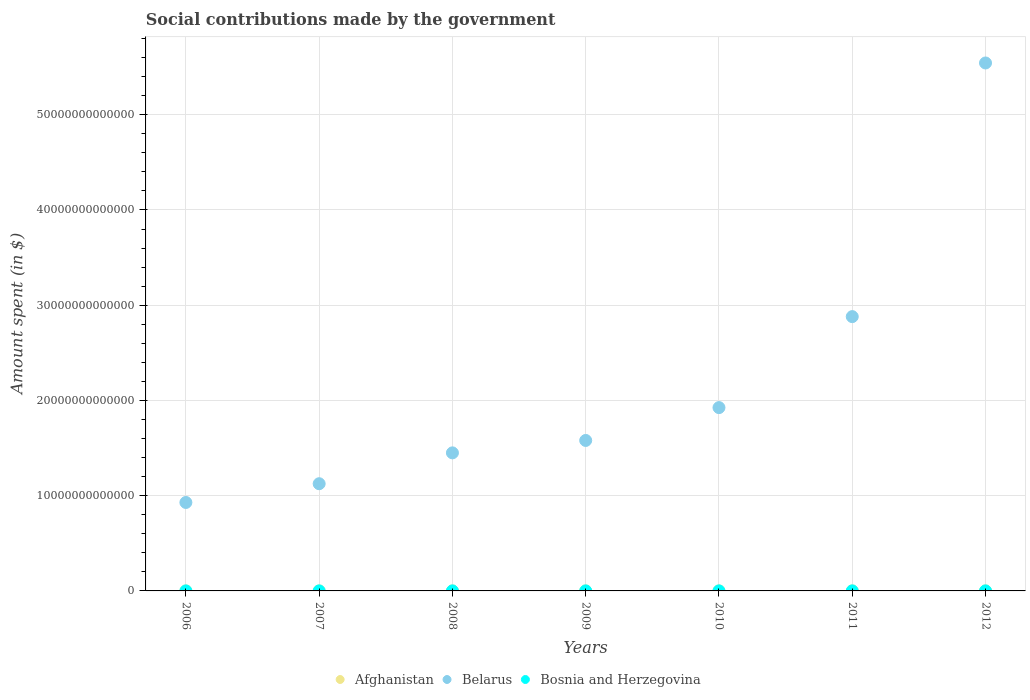How many different coloured dotlines are there?
Your answer should be very brief. 3. What is the amount spent on social contributions in Bosnia and Herzegovina in 2010?
Provide a short and direct response. 3.81e+09. Across all years, what is the maximum amount spent on social contributions in Bosnia and Herzegovina?
Ensure brevity in your answer.  4.05e+09. Across all years, what is the minimum amount spent on social contributions in Afghanistan?
Ensure brevity in your answer.  3.57e+08. In which year was the amount spent on social contributions in Belarus maximum?
Ensure brevity in your answer.  2012. What is the total amount spent on social contributions in Bosnia and Herzegovina in the graph?
Provide a succinct answer. 2.45e+1. What is the difference between the amount spent on social contributions in Belarus in 2008 and that in 2011?
Make the answer very short. -1.43e+13. What is the difference between the amount spent on social contributions in Bosnia and Herzegovina in 2006 and the amount spent on social contributions in Afghanistan in 2008?
Your response must be concise. 1.78e+09. What is the average amount spent on social contributions in Afghanistan per year?
Ensure brevity in your answer.  1.43e+09. In the year 2008, what is the difference between the amount spent on social contributions in Belarus and amount spent on social contributions in Bosnia and Herzegovina?
Make the answer very short. 1.45e+13. In how many years, is the amount spent on social contributions in Belarus greater than 26000000000000 $?
Your response must be concise. 2. What is the ratio of the amount spent on social contributions in Bosnia and Herzegovina in 2006 to that in 2007?
Your answer should be compact. 0.87. Is the amount spent on social contributions in Bosnia and Herzegovina in 2006 less than that in 2012?
Offer a very short reply. Yes. Is the difference between the amount spent on social contributions in Belarus in 2008 and 2010 greater than the difference between the amount spent on social contributions in Bosnia and Herzegovina in 2008 and 2010?
Offer a very short reply. No. What is the difference between the highest and the second highest amount spent on social contributions in Belarus?
Your response must be concise. 2.66e+13. What is the difference between the highest and the lowest amount spent on social contributions in Belarus?
Your response must be concise. 4.61e+13. In how many years, is the amount spent on social contributions in Bosnia and Herzegovina greater than the average amount spent on social contributions in Bosnia and Herzegovina taken over all years?
Ensure brevity in your answer.  5. Does the amount spent on social contributions in Afghanistan monotonically increase over the years?
Offer a terse response. Yes. Is the amount spent on social contributions in Belarus strictly less than the amount spent on social contributions in Bosnia and Herzegovina over the years?
Your response must be concise. No. How many years are there in the graph?
Ensure brevity in your answer.  7. What is the difference between two consecutive major ticks on the Y-axis?
Offer a very short reply. 1.00e+13. Are the values on the major ticks of Y-axis written in scientific E-notation?
Provide a succinct answer. No. Does the graph contain any zero values?
Keep it short and to the point. No. Does the graph contain grids?
Make the answer very short. Yes. Where does the legend appear in the graph?
Give a very brief answer. Bottom center. How are the legend labels stacked?
Your answer should be compact. Horizontal. What is the title of the graph?
Offer a very short reply. Social contributions made by the government. What is the label or title of the Y-axis?
Ensure brevity in your answer.  Amount spent (in $). What is the Amount spent (in $) of Afghanistan in 2006?
Keep it short and to the point. 3.57e+08. What is the Amount spent (in $) in Belarus in 2006?
Keep it short and to the point. 9.29e+12. What is the Amount spent (in $) in Bosnia and Herzegovina in 2006?
Offer a very short reply. 2.54e+09. What is the Amount spent (in $) in Afghanistan in 2007?
Make the answer very short. 3.98e+08. What is the Amount spent (in $) of Belarus in 2007?
Give a very brief answer. 1.13e+13. What is the Amount spent (in $) of Bosnia and Herzegovina in 2007?
Offer a terse response. 2.91e+09. What is the Amount spent (in $) in Afghanistan in 2008?
Offer a terse response. 7.52e+08. What is the Amount spent (in $) of Belarus in 2008?
Ensure brevity in your answer.  1.45e+13. What is the Amount spent (in $) of Bosnia and Herzegovina in 2008?
Give a very brief answer. 3.57e+09. What is the Amount spent (in $) in Afghanistan in 2009?
Your answer should be compact. 9.74e+08. What is the Amount spent (in $) of Belarus in 2009?
Ensure brevity in your answer.  1.58e+13. What is the Amount spent (in $) in Bosnia and Herzegovina in 2009?
Your answer should be compact. 3.64e+09. What is the Amount spent (in $) of Afghanistan in 2010?
Your answer should be compact. 1.65e+09. What is the Amount spent (in $) in Belarus in 2010?
Make the answer very short. 1.92e+13. What is the Amount spent (in $) in Bosnia and Herzegovina in 2010?
Your response must be concise. 3.81e+09. What is the Amount spent (in $) in Afghanistan in 2011?
Your response must be concise. 2.74e+09. What is the Amount spent (in $) of Belarus in 2011?
Your answer should be compact. 2.88e+13. What is the Amount spent (in $) of Bosnia and Herzegovina in 2011?
Provide a short and direct response. 4.04e+09. What is the Amount spent (in $) in Afghanistan in 2012?
Make the answer very short. 3.12e+09. What is the Amount spent (in $) of Belarus in 2012?
Make the answer very short. 5.54e+13. What is the Amount spent (in $) in Bosnia and Herzegovina in 2012?
Your response must be concise. 4.05e+09. Across all years, what is the maximum Amount spent (in $) of Afghanistan?
Your answer should be very brief. 3.12e+09. Across all years, what is the maximum Amount spent (in $) in Belarus?
Give a very brief answer. 5.54e+13. Across all years, what is the maximum Amount spent (in $) in Bosnia and Herzegovina?
Your answer should be very brief. 4.05e+09. Across all years, what is the minimum Amount spent (in $) in Afghanistan?
Provide a short and direct response. 3.57e+08. Across all years, what is the minimum Amount spent (in $) of Belarus?
Your answer should be compact. 9.29e+12. Across all years, what is the minimum Amount spent (in $) of Bosnia and Herzegovina?
Offer a very short reply. 2.54e+09. What is the total Amount spent (in $) in Afghanistan in the graph?
Offer a terse response. 9.99e+09. What is the total Amount spent (in $) in Belarus in the graph?
Your answer should be very brief. 1.54e+14. What is the total Amount spent (in $) of Bosnia and Herzegovina in the graph?
Your answer should be very brief. 2.45e+1. What is the difference between the Amount spent (in $) in Afghanistan in 2006 and that in 2007?
Offer a very short reply. -4.11e+07. What is the difference between the Amount spent (in $) of Belarus in 2006 and that in 2007?
Offer a terse response. -1.97e+12. What is the difference between the Amount spent (in $) of Bosnia and Herzegovina in 2006 and that in 2007?
Provide a short and direct response. -3.73e+08. What is the difference between the Amount spent (in $) of Afghanistan in 2006 and that in 2008?
Your answer should be compact. -3.95e+08. What is the difference between the Amount spent (in $) in Belarus in 2006 and that in 2008?
Your answer should be compact. -5.21e+12. What is the difference between the Amount spent (in $) in Bosnia and Herzegovina in 2006 and that in 2008?
Offer a terse response. -1.03e+09. What is the difference between the Amount spent (in $) of Afghanistan in 2006 and that in 2009?
Give a very brief answer. -6.17e+08. What is the difference between the Amount spent (in $) in Belarus in 2006 and that in 2009?
Your answer should be very brief. -6.51e+12. What is the difference between the Amount spent (in $) of Bosnia and Herzegovina in 2006 and that in 2009?
Your answer should be compact. -1.10e+09. What is the difference between the Amount spent (in $) in Afghanistan in 2006 and that in 2010?
Your answer should be compact. -1.29e+09. What is the difference between the Amount spent (in $) of Belarus in 2006 and that in 2010?
Make the answer very short. -9.96e+12. What is the difference between the Amount spent (in $) of Bosnia and Herzegovina in 2006 and that in 2010?
Offer a very short reply. -1.28e+09. What is the difference between the Amount spent (in $) in Afghanistan in 2006 and that in 2011?
Ensure brevity in your answer.  -2.38e+09. What is the difference between the Amount spent (in $) of Belarus in 2006 and that in 2011?
Make the answer very short. -1.95e+13. What is the difference between the Amount spent (in $) of Bosnia and Herzegovina in 2006 and that in 2011?
Ensure brevity in your answer.  -1.50e+09. What is the difference between the Amount spent (in $) of Afghanistan in 2006 and that in 2012?
Ensure brevity in your answer.  -2.76e+09. What is the difference between the Amount spent (in $) in Belarus in 2006 and that in 2012?
Your answer should be compact. -4.61e+13. What is the difference between the Amount spent (in $) of Bosnia and Herzegovina in 2006 and that in 2012?
Offer a very short reply. -1.51e+09. What is the difference between the Amount spent (in $) in Afghanistan in 2007 and that in 2008?
Ensure brevity in your answer.  -3.54e+08. What is the difference between the Amount spent (in $) in Belarus in 2007 and that in 2008?
Keep it short and to the point. -3.24e+12. What is the difference between the Amount spent (in $) in Bosnia and Herzegovina in 2007 and that in 2008?
Ensure brevity in your answer.  -6.60e+08. What is the difference between the Amount spent (in $) of Afghanistan in 2007 and that in 2009?
Provide a short and direct response. -5.76e+08. What is the difference between the Amount spent (in $) in Belarus in 2007 and that in 2009?
Keep it short and to the point. -4.54e+12. What is the difference between the Amount spent (in $) in Bosnia and Herzegovina in 2007 and that in 2009?
Ensure brevity in your answer.  -7.30e+08. What is the difference between the Amount spent (in $) of Afghanistan in 2007 and that in 2010?
Offer a very short reply. -1.25e+09. What is the difference between the Amount spent (in $) in Belarus in 2007 and that in 2010?
Ensure brevity in your answer.  -7.99e+12. What is the difference between the Amount spent (in $) of Bosnia and Herzegovina in 2007 and that in 2010?
Offer a very short reply. -9.04e+08. What is the difference between the Amount spent (in $) in Afghanistan in 2007 and that in 2011?
Make the answer very short. -2.34e+09. What is the difference between the Amount spent (in $) in Belarus in 2007 and that in 2011?
Your answer should be very brief. -1.75e+13. What is the difference between the Amount spent (in $) in Bosnia and Herzegovina in 2007 and that in 2011?
Offer a terse response. -1.13e+09. What is the difference between the Amount spent (in $) of Afghanistan in 2007 and that in 2012?
Offer a terse response. -2.72e+09. What is the difference between the Amount spent (in $) of Belarus in 2007 and that in 2012?
Make the answer very short. -4.42e+13. What is the difference between the Amount spent (in $) of Bosnia and Herzegovina in 2007 and that in 2012?
Ensure brevity in your answer.  -1.14e+09. What is the difference between the Amount spent (in $) of Afghanistan in 2008 and that in 2009?
Your answer should be very brief. -2.22e+08. What is the difference between the Amount spent (in $) of Belarus in 2008 and that in 2009?
Ensure brevity in your answer.  -1.30e+12. What is the difference between the Amount spent (in $) of Bosnia and Herzegovina in 2008 and that in 2009?
Your answer should be very brief. -6.99e+07. What is the difference between the Amount spent (in $) of Afghanistan in 2008 and that in 2010?
Provide a succinct answer. -8.98e+08. What is the difference between the Amount spent (in $) of Belarus in 2008 and that in 2010?
Give a very brief answer. -4.75e+12. What is the difference between the Amount spent (in $) in Bosnia and Herzegovina in 2008 and that in 2010?
Your answer should be compact. -2.44e+08. What is the difference between the Amount spent (in $) in Afghanistan in 2008 and that in 2011?
Your answer should be very brief. -1.98e+09. What is the difference between the Amount spent (in $) of Belarus in 2008 and that in 2011?
Ensure brevity in your answer.  -1.43e+13. What is the difference between the Amount spent (in $) in Bosnia and Herzegovina in 2008 and that in 2011?
Your answer should be compact. -4.68e+08. What is the difference between the Amount spent (in $) in Afghanistan in 2008 and that in 2012?
Your response must be concise. -2.37e+09. What is the difference between the Amount spent (in $) of Belarus in 2008 and that in 2012?
Offer a terse response. -4.09e+13. What is the difference between the Amount spent (in $) in Bosnia and Herzegovina in 2008 and that in 2012?
Offer a very short reply. -4.78e+08. What is the difference between the Amount spent (in $) of Afghanistan in 2009 and that in 2010?
Offer a very short reply. -6.76e+08. What is the difference between the Amount spent (in $) of Belarus in 2009 and that in 2010?
Give a very brief answer. -3.45e+12. What is the difference between the Amount spent (in $) of Bosnia and Herzegovina in 2009 and that in 2010?
Offer a terse response. -1.75e+08. What is the difference between the Amount spent (in $) of Afghanistan in 2009 and that in 2011?
Provide a succinct answer. -1.76e+09. What is the difference between the Amount spent (in $) in Belarus in 2009 and that in 2011?
Give a very brief answer. -1.30e+13. What is the difference between the Amount spent (in $) of Bosnia and Herzegovina in 2009 and that in 2011?
Give a very brief answer. -3.98e+08. What is the difference between the Amount spent (in $) in Afghanistan in 2009 and that in 2012?
Offer a terse response. -2.14e+09. What is the difference between the Amount spent (in $) in Belarus in 2009 and that in 2012?
Provide a short and direct response. -3.96e+13. What is the difference between the Amount spent (in $) of Bosnia and Herzegovina in 2009 and that in 2012?
Offer a terse response. -4.08e+08. What is the difference between the Amount spent (in $) of Afghanistan in 2010 and that in 2011?
Offer a very short reply. -1.08e+09. What is the difference between the Amount spent (in $) in Belarus in 2010 and that in 2011?
Your answer should be very brief. -9.55e+12. What is the difference between the Amount spent (in $) of Bosnia and Herzegovina in 2010 and that in 2011?
Offer a terse response. -2.23e+08. What is the difference between the Amount spent (in $) of Afghanistan in 2010 and that in 2012?
Your answer should be very brief. -1.47e+09. What is the difference between the Amount spent (in $) in Belarus in 2010 and that in 2012?
Ensure brevity in your answer.  -3.62e+13. What is the difference between the Amount spent (in $) in Bosnia and Herzegovina in 2010 and that in 2012?
Your answer should be compact. -2.34e+08. What is the difference between the Amount spent (in $) in Afghanistan in 2011 and that in 2012?
Offer a very short reply. -3.83e+08. What is the difference between the Amount spent (in $) of Belarus in 2011 and that in 2012?
Provide a short and direct response. -2.66e+13. What is the difference between the Amount spent (in $) in Bosnia and Herzegovina in 2011 and that in 2012?
Provide a short and direct response. -1.03e+07. What is the difference between the Amount spent (in $) in Afghanistan in 2006 and the Amount spent (in $) in Belarus in 2007?
Provide a short and direct response. -1.13e+13. What is the difference between the Amount spent (in $) in Afghanistan in 2006 and the Amount spent (in $) in Bosnia and Herzegovina in 2007?
Keep it short and to the point. -2.55e+09. What is the difference between the Amount spent (in $) of Belarus in 2006 and the Amount spent (in $) of Bosnia and Herzegovina in 2007?
Your answer should be compact. 9.28e+12. What is the difference between the Amount spent (in $) of Afghanistan in 2006 and the Amount spent (in $) of Belarus in 2008?
Ensure brevity in your answer.  -1.45e+13. What is the difference between the Amount spent (in $) in Afghanistan in 2006 and the Amount spent (in $) in Bosnia and Herzegovina in 2008?
Give a very brief answer. -3.21e+09. What is the difference between the Amount spent (in $) in Belarus in 2006 and the Amount spent (in $) in Bosnia and Herzegovina in 2008?
Provide a succinct answer. 9.28e+12. What is the difference between the Amount spent (in $) of Afghanistan in 2006 and the Amount spent (in $) of Belarus in 2009?
Give a very brief answer. -1.58e+13. What is the difference between the Amount spent (in $) in Afghanistan in 2006 and the Amount spent (in $) in Bosnia and Herzegovina in 2009?
Ensure brevity in your answer.  -3.28e+09. What is the difference between the Amount spent (in $) of Belarus in 2006 and the Amount spent (in $) of Bosnia and Herzegovina in 2009?
Provide a short and direct response. 9.28e+12. What is the difference between the Amount spent (in $) of Afghanistan in 2006 and the Amount spent (in $) of Belarus in 2010?
Your answer should be compact. -1.92e+13. What is the difference between the Amount spent (in $) of Afghanistan in 2006 and the Amount spent (in $) of Bosnia and Herzegovina in 2010?
Your response must be concise. -3.46e+09. What is the difference between the Amount spent (in $) of Belarus in 2006 and the Amount spent (in $) of Bosnia and Herzegovina in 2010?
Provide a succinct answer. 9.28e+12. What is the difference between the Amount spent (in $) of Afghanistan in 2006 and the Amount spent (in $) of Belarus in 2011?
Your answer should be very brief. -2.88e+13. What is the difference between the Amount spent (in $) of Afghanistan in 2006 and the Amount spent (in $) of Bosnia and Herzegovina in 2011?
Offer a terse response. -3.68e+09. What is the difference between the Amount spent (in $) of Belarus in 2006 and the Amount spent (in $) of Bosnia and Herzegovina in 2011?
Your answer should be compact. 9.28e+12. What is the difference between the Amount spent (in $) of Afghanistan in 2006 and the Amount spent (in $) of Belarus in 2012?
Offer a very short reply. -5.54e+13. What is the difference between the Amount spent (in $) of Afghanistan in 2006 and the Amount spent (in $) of Bosnia and Herzegovina in 2012?
Provide a short and direct response. -3.69e+09. What is the difference between the Amount spent (in $) in Belarus in 2006 and the Amount spent (in $) in Bosnia and Herzegovina in 2012?
Your response must be concise. 9.28e+12. What is the difference between the Amount spent (in $) of Afghanistan in 2007 and the Amount spent (in $) of Belarus in 2008?
Provide a short and direct response. -1.45e+13. What is the difference between the Amount spent (in $) in Afghanistan in 2007 and the Amount spent (in $) in Bosnia and Herzegovina in 2008?
Make the answer very short. -3.17e+09. What is the difference between the Amount spent (in $) in Belarus in 2007 and the Amount spent (in $) in Bosnia and Herzegovina in 2008?
Give a very brief answer. 1.13e+13. What is the difference between the Amount spent (in $) of Afghanistan in 2007 and the Amount spent (in $) of Belarus in 2009?
Your answer should be very brief. -1.58e+13. What is the difference between the Amount spent (in $) in Afghanistan in 2007 and the Amount spent (in $) in Bosnia and Herzegovina in 2009?
Your response must be concise. -3.24e+09. What is the difference between the Amount spent (in $) in Belarus in 2007 and the Amount spent (in $) in Bosnia and Herzegovina in 2009?
Offer a terse response. 1.13e+13. What is the difference between the Amount spent (in $) in Afghanistan in 2007 and the Amount spent (in $) in Belarus in 2010?
Ensure brevity in your answer.  -1.92e+13. What is the difference between the Amount spent (in $) in Afghanistan in 2007 and the Amount spent (in $) in Bosnia and Herzegovina in 2010?
Make the answer very short. -3.41e+09. What is the difference between the Amount spent (in $) of Belarus in 2007 and the Amount spent (in $) of Bosnia and Herzegovina in 2010?
Make the answer very short. 1.13e+13. What is the difference between the Amount spent (in $) of Afghanistan in 2007 and the Amount spent (in $) of Belarus in 2011?
Your answer should be compact. -2.88e+13. What is the difference between the Amount spent (in $) of Afghanistan in 2007 and the Amount spent (in $) of Bosnia and Herzegovina in 2011?
Ensure brevity in your answer.  -3.64e+09. What is the difference between the Amount spent (in $) in Belarus in 2007 and the Amount spent (in $) in Bosnia and Herzegovina in 2011?
Provide a short and direct response. 1.13e+13. What is the difference between the Amount spent (in $) in Afghanistan in 2007 and the Amount spent (in $) in Belarus in 2012?
Offer a very short reply. -5.54e+13. What is the difference between the Amount spent (in $) of Afghanistan in 2007 and the Amount spent (in $) of Bosnia and Herzegovina in 2012?
Make the answer very short. -3.65e+09. What is the difference between the Amount spent (in $) of Belarus in 2007 and the Amount spent (in $) of Bosnia and Herzegovina in 2012?
Ensure brevity in your answer.  1.13e+13. What is the difference between the Amount spent (in $) of Afghanistan in 2008 and the Amount spent (in $) of Belarus in 2009?
Your response must be concise. -1.58e+13. What is the difference between the Amount spent (in $) in Afghanistan in 2008 and the Amount spent (in $) in Bosnia and Herzegovina in 2009?
Keep it short and to the point. -2.89e+09. What is the difference between the Amount spent (in $) in Belarus in 2008 and the Amount spent (in $) in Bosnia and Herzegovina in 2009?
Make the answer very short. 1.45e+13. What is the difference between the Amount spent (in $) of Afghanistan in 2008 and the Amount spent (in $) of Belarus in 2010?
Offer a terse response. -1.92e+13. What is the difference between the Amount spent (in $) in Afghanistan in 2008 and the Amount spent (in $) in Bosnia and Herzegovina in 2010?
Provide a short and direct response. -3.06e+09. What is the difference between the Amount spent (in $) in Belarus in 2008 and the Amount spent (in $) in Bosnia and Herzegovina in 2010?
Your response must be concise. 1.45e+13. What is the difference between the Amount spent (in $) in Afghanistan in 2008 and the Amount spent (in $) in Belarus in 2011?
Provide a short and direct response. -2.88e+13. What is the difference between the Amount spent (in $) in Afghanistan in 2008 and the Amount spent (in $) in Bosnia and Herzegovina in 2011?
Ensure brevity in your answer.  -3.28e+09. What is the difference between the Amount spent (in $) in Belarus in 2008 and the Amount spent (in $) in Bosnia and Herzegovina in 2011?
Your response must be concise. 1.45e+13. What is the difference between the Amount spent (in $) in Afghanistan in 2008 and the Amount spent (in $) in Belarus in 2012?
Make the answer very short. -5.54e+13. What is the difference between the Amount spent (in $) of Afghanistan in 2008 and the Amount spent (in $) of Bosnia and Herzegovina in 2012?
Your answer should be compact. -3.29e+09. What is the difference between the Amount spent (in $) in Belarus in 2008 and the Amount spent (in $) in Bosnia and Herzegovina in 2012?
Your answer should be very brief. 1.45e+13. What is the difference between the Amount spent (in $) in Afghanistan in 2009 and the Amount spent (in $) in Belarus in 2010?
Provide a short and direct response. -1.92e+13. What is the difference between the Amount spent (in $) of Afghanistan in 2009 and the Amount spent (in $) of Bosnia and Herzegovina in 2010?
Make the answer very short. -2.84e+09. What is the difference between the Amount spent (in $) in Belarus in 2009 and the Amount spent (in $) in Bosnia and Herzegovina in 2010?
Keep it short and to the point. 1.58e+13. What is the difference between the Amount spent (in $) of Afghanistan in 2009 and the Amount spent (in $) of Belarus in 2011?
Provide a succinct answer. -2.88e+13. What is the difference between the Amount spent (in $) in Afghanistan in 2009 and the Amount spent (in $) in Bosnia and Herzegovina in 2011?
Ensure brevity in your answer.  -3.06e+09. What is the difference between the Amount spent (in $) of Belarus in 2009 and the Amount spent (in $) of Bosnia and Herzegovina in 2011?
Provide a succinct answer. 1.58e+13. What is the difference between the Amount spent (in $) in Afghanistan in 2009 and the Amount spent (in $) in Belarus in 2012?
Keep it short and to the point. -5.54e+13. What is the difference between the Amount spent (in $) of Afghanistan in 2009 and the Amount spent (in $) of Bosnia and Herzegovina in 2012?
Offer a very short reply. -3.07e+09. What is the difference between the Amount spent (in $) in Belarus in 2009 and the Amount spent (in $) in Bosnia and Herzegovina in 2012?
Offer a very short reply. 1.58e+13. What is the difference between the Amount spent (in $) in Afghanistan in 2010 and the Amount spent (in $) in Belarus in 2011?
Your answer should be compact. -2.88e+13. What is the difference between the Amount spent (in $) of Afghanistan in 2010 and the Amount spent (in $) of Bosnia and Herzegovina in 2011?
Your answer should be compact. -2.39e+09. What is the difference between the Amount spent (in $) of Belarus in 2010 and the Amount spent (in $) of Bosnia and Herzegovina in 2011?
Offer a terse response. 1.92e+13. What is the difference between the Amount spent (in $) of Afghanistan in 2010 and the Amount spent (in $) of Belarus in 2012?
Ensure brevity in your answer.  -5.54e+13. What is the difference between the Amount spent (in $) in Afghanistan in 2010 and the Amount spent (in $) in Bosnia and Herzegovina in 2012?
Your response must be concise. -2.40e+09. What is the difference between the Amount spent (in $) of Belarus in 2010 and the Amount spent (in $) of Bosnia and Herzegovina in 2012?
Provide a succinct answer. 1.92e+13. What is the difference between the Amount spent (in $) in Afghanistan in 2011 and the Amount spent (in $) in Belarus in 2012?
Offer a very short reply. -5.54e+13. What is the difference between the Amount spent (in $) of Afghanistan in 2011 and the Amount spent (in $) of Bosnia and Herzegovina in 2012?
Your answer should be compact. -1.31e+09. What is the difference between the Amount spent (in $) in Belarus in 2011 and the Amount spent (in $) in Bosnia and Herzegovina in 2012?
Offer a terse response. 2.88e+13. What is the average Amount spent (in $) of Afghanistan per year?
Your answer should be very brief. 1.43e+09. What is the average Amount spent (in $) of Belarus per year?
Ensure brevity in your answer.  2.20e+13. What is the average Amount spent (in $) of Bosnia and Herzegovina per year?
Offer a very short reply. 3.51e+09. In the year 2006, what is the difference between the Amount spent (in $) of Afghanistan and Amount spent (in $) of Belarus?
Offer a very short reply. -9.29e+12. In the year 2006, what is the difference between the Amount spent (in $) of Afghanistan and Amount spent (in $) of Bosnia and Herzegovina?
Offer a terse response. -2.18e+09. In the year 2006, what is the difference between the Amount spent (in $) in Belarus and Amount spent (in $) in Bosnia and Herzegovina?
Offer a very short reply. 9.29e+12. In the year 2007, what is the difference between the Amount spent (in $) of Afghanistan and Amount spent (in $) of Belarus?
Offer a very short reply. -1.13e+13. In the year 2007, what is the difference between the Amount spent (in $) in Afghanistan and Amount spent (in $) in Bosnia and Herzegovina?
Offer a terse response. -2.51e+09. In the year 2007, what is the difference between the Amount spent (in $) of Belarus and Amount spent (in $) of Bosnia and Herzegovina?
Give a very brief answer. 1.13e+13. In the year 2008, what is the difference between the Amount spent (in $) in Afghanistan and Amount spent (in $) in Belarus?
Provide a short and direct response. -1.45e+13. In the year 2008, what is the difference between the Amount spent (in $) of Afghanistan and Amount spent (in $) of Bosnia and Herzegovina?
Your answer should be very brief. -2.82e+09. In the year 2008, what is the difference between the Amount spent (in $) of Belarus and Amount spent (in $) of Bosnia and Herzegovina?
Ensure brevity in your answer.  1.45e+13. In the year 2009, what is the difference between the Amount spent (in $) of Afghanistan and Amount spent (in $) of Belarus?
Make the answer very short. -1.58e+13. In the year 2009, what is the difference between the Amount spent (in $) of Afghanistan and Amount spent (in $) of Bosnia and Herzegovina?
Give a very brief answer. -2.66e+09. In the year 2009, what is the difference between the Amount spent (in $) in Belarus and Amount spent (in $) in Bosnia and Herzegovina?
Offer a terse response. 1.58e+13. In the year 2010, what is the difference between the Amount spent (in $) of Afghanistan and Amount spent (in $) of Belarus?
Offer a very short reply. -1.92e+13. In the year 2010, what is the difference between the Amount spent (in $) in Afghanistan and Amount spent (in $) in Bosnia and Herzegovina?
Keep it short and to the point. -2.16e+09. In the year 2010, what is the difference between the Amount spent (in $) in Belarus and Amount spent (in $) in Bosnia and Herzegovina?
Provide a short and direct response. 1.92e+13. In the year 2011, what is the difference between the Amount spent (in $) of Afghanistan and Amount spent (in $) of Belarus?
Provide a succinct answer. -2.88e+13. In the year 2011, what is the difference between the Amount spent (in $) of Afghanistan and Amount spent (in $) of Bosnia and Herzegovina?
Your response must be concise. -1.30e+09. In the year 2011, what is the difference between the Amount spent (in $) in Belarus and Amount spent (in $) in Bosnia and Herzegovina?
Provide a succinct answer. 2.88e+13. In the year 2012, what is the difference between the Amount spent (in $) of Afghanistan and Amount spent (in $) of Belarus?
Your answer should be compact. -5.54e+13. In the year 2012, what is the difference between the Amount spent (in $) in Afghanistan and Amount spent (in $) in Bosnia and Herzegovina?
Offer a very short reply. -9.28e+08. In the year 2012, what is the difference between the Amount spent (in $) in Belarus and Amount spent (in $) in Bosnia and Herzegovina?
Your answer should be very brief. 5.54e+13. What is the ratio of the Amount spent (in $) of Afghanistan in 2006 to that in 2007?
Keep it short and to the point. 0.9. What is the ratio of the Amount spent (in $) of Belarus in 2006 to that in 2007?
Your answer should be compact. 0.83. What is the ratio of the Amount spent (in $) in Bosnia and Herzegovina in 2006 to that in 2007?
Keep it short and to the point. 0.87. What is the ratio of the Amount spent (in $) in Afghanistan in 2006 to that in 2008?
Give a very brief answer. 0.48. What is the ratio of the Amount spent (in $) in Belarus in 2006 to that in 2008?
Your answer should be compact. 0.64. What is the ratio of the Amount spent (in $) of Bosnia and Herzegovina in 2006 to that in 2008?
Your answer should be compact. 0.71. What is the ratio of the Amount spent (in $) in Afghanistan in 2006 to that in 2009?
Your answer should be compact. 0.37. What is the ratio of the Amount spent (in $) of Belarus in 2006 to that in 2009?
Keep it short and to the point. 0.59. What is the ratio of the Amount spent (in $) in Bosnia and Herzegovina in 2006 to that in 2009?
Keep it short and to the point. 0.7. What is the ratio of the Amount spent (in $) of Afghanistan in 2006 to that in 2010?
Your answer should be compact. 0.22. What is the ratio of the Amount spent (in $) of Belarus in 2006 to that in 2010?
Offer a terse response. 0.48. What is the ratio of the Amount spent (in $) in Bosnia and Herzegovina in 2006 to that in 2010?
Offer a terse response. 0.67. What is the ratio of the Amount spent (in $) in Afghanistan in 2006 to that in 2011?
Your answer should be compact. 0.13. What is the ratio of the Amount spent (in $) of Belarus in 2006 to that in 2011?
Ensure brevity in your answer.  0.32. What is the ratio of the Amount spent (in $) in Bosnia and Herzegovina in 2006 to that in 2011?
Your response must be concise. 0.63. What is the ratio of the Amount spent (in $) in Afghanistan in 2006 to that in 2012?
Keep it short and to the point. 0.11. What is the ratio of the Amount spent (in $) in Belarus in 2006 to that in 2012?
Your answer should be very brief. 0.17. What is the ratio of the Amount spent (in $) in Bosnia and Herzegovina in 2006 to that in 2012?
Give a very brief answer. 0.63. What is the ratio of the Amount spent (in $) of Afghanistan in 2007 to that in 2008?
Provide a succinct answer. 0.53. What is the ratio of the Amount spent (in $) in Belarus in 2007 to that in 2008?
Give a very brief answer. 0.78. What is the ratio of the Amount spent (in $) of Bosnia and Herzegovina in 2007 to that in 2008?
Your response must be concise. 0.82. What is the ratio of the Amount spent (in $) in Afghanistan in 2007 to that in 2009?
Your answer should be very brief. 0.41. What is the ratio of the Amount spent (in $) of Belarus in 2007 to that in 2009?
Make the answer very short. 0.71. What is the ratio of the Amount spent (in $) of Bosnia and Herzegovina in 2007 to that in 2009?
Your answer should be very brief. 0.8. What is the ratio of the Amount spent (in $) in Afghanistan in 2007 to that in 2010?
Offer a terse response. 0.24. What is the ratio of the Amount spent (in $) of Belarus in 2007 to that in 2010?
Keep it short and to the point. 0.58. What is the ratio of the Amount spent (in $) of Bosnia and Herzegovina in 2007 to that in 2010?
Offer a terse response. 0.76. What is the ratio of the Amount spent (in $) of Afghanistan in 2007 to that in 2011?
Offer a very short reply. 0.15. What is the ratio of the Amount spent (in $) of Belarus in 2007 to that in 2011?
Keep it short and to the point. 0.39. What is the ratio of the Amount spent (in $) of Bosnia and Herzegovina in 2007 to that in 2011?
Offer a very short reply. 0.72. What is the ratio of the Amount spent (in $) in Afghanistan in 2007 to that in 2012?
Make the answer very short. 0.13. What is the ratio of the Amount spent (in $) in Belarus in 2007 to that in 2012?
Keep it short and to the point. 0.2. What is the ratio of the Amount spent (in $) of Bosnia and Herzegovina in 2007 to that in 2012?
Provide a short and direct response. 0.72. What is the ratio of the Amount spent (in $) in Afghanistan in 2008 to that in 2009?
Your response must be concise. 0.77. What is the ratio of the Amount spent (in $) of Belarus in 2008 to that in 2009?
Your answer should be compact. 0.92. What is the ratio of the Amount spent (in $) of Bosnia and Herzegovina in 2008 to that in 2009?
Offer a very short reply. 0.98. What is the ratio of the Amount spent (in $) in Afghanistan in 2008 to that in 2010?
Offer a very short reply. 0.46. What is the ratio of the Amount spent (in $) in Belarus in 2008 to that in 2010?
Offer a very short reply. 0.75. What is the ratio of the Amount spent (in $) in Bosnia and Herzegovina in 2008 to that in 2010?
Offer a very short reply. 0.94. What is the ratio of the Amount spent (in $) of Afghanistan in 2008 to that in 2011?
Offer a very short reply. 0.27. What is the ratio of the Amount spent (in $) of Belarus in 2008 to that in 2011?
Offer a very short reply. 0.5. What is the ratio of the Amount spent (in $) of Bosnia and Herzegovina in 2008 to that in 2011?
Your answer should be compact. 0.88. What is the ratio of the Amount spent (in $) of Afghanistan in 2008 to that in 2012?
Ensure brevity in your answer.  0.24. What is the ratio of the Amount spent (in $) of Belarus in 2008 to that in 2012?
Offer a terse response. 0.26. What is the ratio of the Amount spent (in $) in Bosnia and Herzegovina in 2008 to that in 2012?
Offer a very short reply. 0.88. What is the ratio of the Amount spent (in $) of Afghanistan in 2009 to that in 2010?
Keep it short and to the point. 0.59. What is the ratio of the Amount spent (in $) of Belarus in 2009 to that in 2010?
Offer a terse response. 0.82. What is the ratio of the Amount spent (in $) of Bosnia and Herzegovina in 2009 to that in 2010?
Keep it short and to the point. 0.95. What is the ratio of the Amount spent (in $) of Afghanistan in 2009 to that in 2011?
Give a very brief answer. 0.36. What is the ratio of the Amount spent (in $) in Belarus in 2009 to that in 2011?
Offer a very short reply. 0.55. What is the ratio of the Amount spent (in $) in Bosnia and Herzegovina in 2009 to that in 2011?
Give a very brief answer. 0.9. What is the ratio of the Amount spent (in $) in Afghanistan in 2009 to that in 2012?
Offer a very short reply. 0.31. What is the ratio of the Amount spent (in $) in Belarus in 2009 to that in 2012?
Offer a very short reply. 0.28. What is the ratio of the Amount spent (in $) of Bosnia and Herzegovina in 2009 to that in 2012?
Offer a very short reply. 0.9. What is the ratio of the Amount spent (in $) of Afghanistan in 2010 to that in 2011?
Your answer should be very brief. 0.6. What is the ratio of the Amount spent (in $) of Belarus in 2010 to that in 2011?
Provide a succinct answer. 0.67. What is the ratio of the Amount spent (in $) of Bosnia and Herzegovina in 2010 to that in 2011?
Your answer should be compact. 0.94. What is the ratio of the Amount spent (in $) in Afghanistan in 2010 to that in 2012?
Ensure brevity in your answer.  0.53. What is the ratio of the Amount spent (in $) in Belarus in 2010 to that in 2012?
Your response must be concise. 0.35. What is the ratio of the Amount spent (in $) of Bosnia and Herzegovina in 2010 to that in 2012?
Give a very brief answer. 0.94. What is the ratio of the Amount spent (in $) in Afghanistan in 2011 to that in 2012?
Ensure brevity in your answer.  0.88. What is the ratio of the Amount spent (in $) in Belarus in 2011 to that in 2012?
Your response must be concise. 0.52. What is the ratio of the Amount spent (in $) of Bosnia and Herzegovina in 2011 to that in 2012?
Ensure brevity in your answer.  1. What is the difference between the highest and the second highest Amount spent (in $) in Afghanistan?
Ensure brevity in your answer.  3.83e+08. What is the difference between the highest and the second highest Amount spent (in $) in Belarus?
Make the answer very short. 2.66e+13. What is the difference between the highest and the second highest Amount spent (in $) of Bosnia and Herzegovina?
Your answer should be very brief. 1.03e+07. What is the difference between the highest and the lowest Amount spent (in $) in Afghanistan?
Make the answer very short. 2.76e+09. What is the difference between the highest and the lowest Amount spent (in $) of Belarus?
Make the answer very short. 4.61e+13. What is the difference between the highest and the lowest Amount spent (in $) of Bosnia and Herzegovina?
Provide a short and direct response. 1.51e+09. 